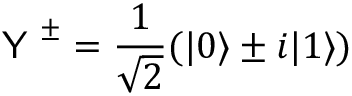<formula> <loc_0><loc_0><loc_500><loc_500>Y ^ { \pm } = \frac { 1 } { \sqrt { 2 } } ( | 0 \rangle \pm i | 1 \rangle )</formula> 